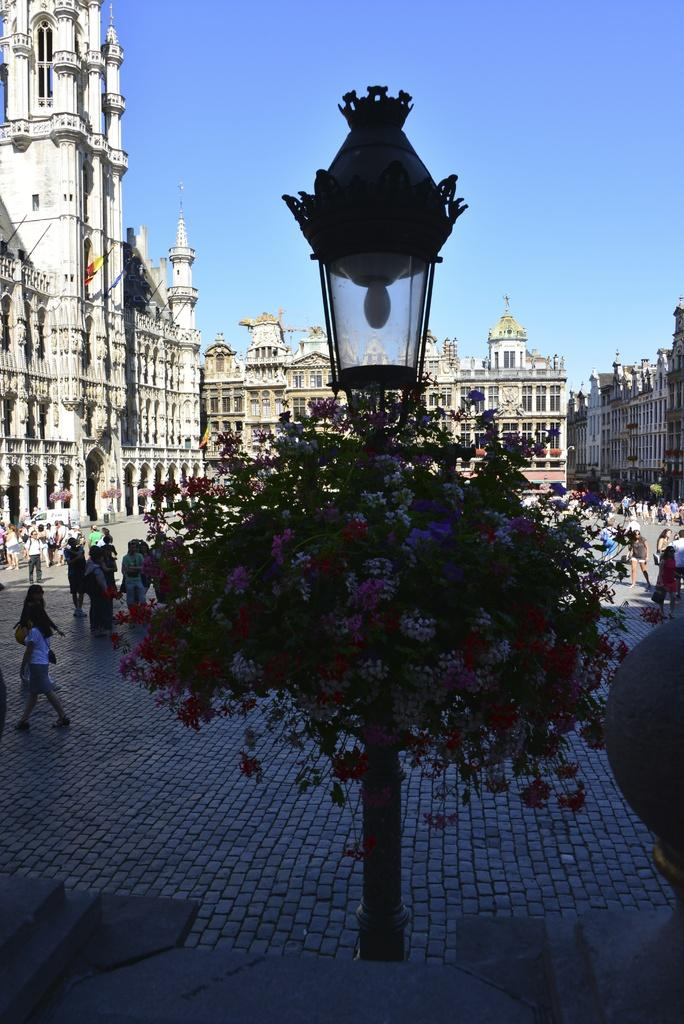What type of structures can be seen in the background of the image? There are buildings in the background of the image. What is happening in front of the buildings? There are people in front of the buildings. Can you describe the lighting in the image? There is a light in the image. What type of vegetation is present in the image? Pink and white flowers with green leaves are present in the image. What type of question can be seen being asked in the image? There is no question visible in the image. Is there any popcorn present in the image? There is no popcorn present in the image. 